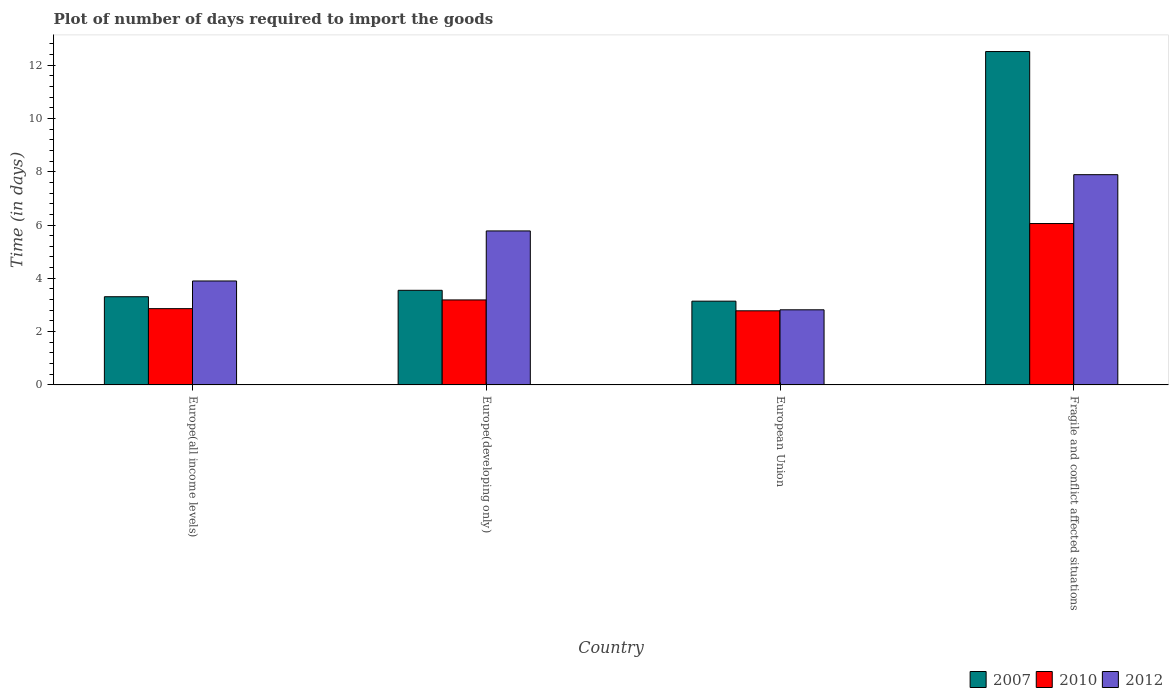How many bars are there on the 2nd tick from the right?
Ensure brevity in your answer.  3. What is the label of the 2nd group of bars from the left?
Provide a succinct answer. Europe(developing only). In how many cases, is the number of bars for a given country not equal to the number of legend labels?
Provide a succinct answer. 0. What is the time required to import goods in 2012 in Fragile and conflict affected situations?
Keep it short and to the point. 7.89. Across all countries, what is the maximum time required to import goods in 2012?
Ensure brevity in your answer.  7.89. Across all countries, what is the minimum time required to import goods in 2007?
Your answer should be very brief. 3.14. In which country was the time required to import goods in 2007 maximum?
Give a very brief answer. Fragile and conflict affected situations. In which country was the time required to import goods in 2012 minimum?
Your answer should be very brief. European Union. What is the total time required to import goods in 2010 in the graph?
Your answer should be very brief. 14.89. What is the difference between the time required to import goods in 2010 in Europe(developing only) and that in Fragile and conflict affected situations?
Make the answer very short. -2.87. What is the difference between the time required to import goods in 2010 in Europe(developing only) and the time required to import goods in 2012 in Europe(all income levels)?
Offer a very short reply. -0.71. What is the average time required to import goods in 2012 per country?
Offer a terse response. 5.1. What is the difference between the time required to import goods of/in 2012 and time required to import goods of/in 2007 in European Union?
Ensure brevity in your answer.  -0.32. What is the ratio of the time required to import goods in 2010 in Europe(all income levels) to that in Fragile and conflict affected situations?
Provide a short and direct response. 0.47. Is the difference between the time required to import goods in 2012 in Europe(developing only) and Fragile and conflict affected situations greater than the difference between the time required to import goods in 2007 in Europe(developing only) and Fragile and conflict affected situations?
Give a very brief answer. Yes. What is the difference between the highest and the second highest time required to import goods in 2012?
Your response must be concise. -1.88. What is the difference between the highest and the lowest time required to import goods in 2010?
Provide a short and direct response. 3.27. In how many countries, is the time required to import goods in 2010 greater than the average time required to import goods in 2010 taken over all countries?
Your answer should be very brief. 1. Are all the bars in the graph horizontal?
Your response must be concise. No. How many countries are there in the graph?
Provide a short and direct response. 4. What is the difference between two consecutive major ticks on the Y-axis?
Provide a short and direct response. 2. Are the values on the major ticks of Y-axis written in scientific E-notation?
Your response must be concise. No. Does the graph contain any zero values?
Provide a succinct answer. No. Does the graph contain grids?
Offer a very short reply. No. What is the title of the graph?
Provide a succinct answer. Plot of number of days required to import the goods. What is the label or title of the X-axis?
Your answer should be very brief. Country. What is the label or title of the Y-axis?
Offer a very short reply. Time (in days). What is the Time (in days) in 2007 in Europe(all income levels)?
Provide a succinct answer. 3.31. What is the Time (in days) in 2010 in Europe(all income levels)?
Your answer should be compact. 2.86. What is the Time (in days) of 2012 in Europe(all income levels)?
Provide a short and direct response. 3.9. What is the Time (in days) in 2007 in Europe(developing only)?
Ensure brevity in your answer.  3.55. What is the Time (in days) of 2010 in Europe(developing only)?
Offer a very short reply. 3.19. What is the Time (in days) of 2012 in Europe(developing only)?
Offer a very short reply. 5.78. What is the Time (in days) of 2007 in European Union?
Keep it short and to the point. 3.14. What is the Time (in days) of 2010 in European Union?
Keep it short and to the point. 2.78. What is the Time (in days) in 2012 in European Union?
Make the answer very short. 2.82. What is the Time (in days) of 2007 in Fragile and conflict affected situations?
Your answer should be compact. 12.51. What is the Time (in days) in 2010 in Fragile and conflict affected situations?
Provide a succinct answer. 6.05. What is the Time (in days) of 2012 in Fragile and conflict affected situations?
Ensure brevity in your answer.  7.89. Across all countries, what is the maximum Time (in days) of 2007?
Provide a short and direct response. 12.51. Across all countries, what is the maximum Time (in days) of 2010?
Offer a terse response. 6.05. Across all countries, what is the maximum Time (in days) of 2012?
Your answer should be very brief. 7.89. Across all countries, what is the minimum Time (in days) of 2007?
Offer a very short reply. 3.14. Across all countries, what is the minimum Time (in days) of 2010?
Give a very brief answer. 2.78. Across all countries, what is the minimum Time (in days) of 2012?
Make the answer very short. 2.82. What is the total Time (in days) in 2007 in the graph?
Your answer should be compact. 22.51. What is the total Time (in days) of 2010 in the graph?
Offer a very short reply. 14.89. What is the total Time (in days) in 2012 in the graph?
Your response must be concise. 20.38. What is the difference between the Time (in days) in 2007 in Europe(all income levels) and that in Europe(developing only)?
Your answer should be very brief. -0.24. What is the difference between the Time (in days) of 2010 in Europe(all income levels) and that in Europe(developing only)?
Make the answer very short. -0.33. What is the difference between the Time (in days) in 2012 in Europe(all income levels) and that in Europe(developing only)?
Make the answer very short. -1.88. What is the difference between the Time (in days) in 2007 in Europe(all income levels) and that in European Union?
Your answer should be very brief. 0.17. What is the difference between the Time (in days) in 2010 in Europe(all income levels) and that in European Union?
Your answer should be very brief. 0.08. What is the difference between the Time (in days) in 2012 in Europe(all income levels) and that in European Union?
Your answer should be compact. 1.08. What is the difference between the Time (in days) of 2010 in Europe(all income levels) and that in Fragile and conflict affected situations?
Ensure brevity in your answer.  -3.19. What is the difference between the Time (in days) of 2012 in Europe(all income levels) and that in Fragile and conflict affected situations?
Your answer should be compact. -3.99. What is the difference between the Time (in days) in 2007 in Europe(developing only) and that in European Union?
Provide a short and direct response. 0.41. What is the difference between the Time (in days) in 2010 in Europe(developing only) and that in European Union?
Your response must be concise. 0.41. What is the difference between the Time (in days) in 2012 in Europe(developing only) and that in European Union?
Make the answer very short. 2.96. What is the difference between the Time (in days) of 2007 in Europe(developing only) and that in Fragile and conflict affected situations?
Give a very brief answer. -8.96. What is the difference between the Time (in days) in 2010 in Europe(developing only) and that in Fragile and conflict affected situations?
Make the answer very short. -2.87. What is the difference between the Time (in days) of 2012 in Europe(developing only) and that in Fragile and conflict affected situations?
Ensure brevity in your answer.  -2.11. What is the difference between the Time (in days) in 2007 in European Union and that in Fragile and conflict affected situations?
Your answer should be compact. -9.37. What is the difference between the Time (in days) in 2010 in European Union and that in Fragile and conflict affected situations?
Your answer should be very brief. -3.27. What is the difference between the Time (in days) of 2012 in European Union and that in Fragile and conflict affected situations?
Provide a succinct answer. -5.07. What is the difference between the Time (in days) of 2007 in Europe(all income levels) and the Time (in days) of 2010 in Europe(developing only)?
Your answer should be very brief. 0.12. What is the difference between the Time (in days) of 2007 in Europe(all income levels) and the Time (in days) of 2012 in Europe(developing only)?
Provide a short and direct response. -2.47. What is the difference between the Time (in days) of 2010 in Europe(all income levels) and the Time (in days) of 2012 in Europe(developing only)?
Ensure brevity in your answer.  -2.92. What is the difference between the Time (in days) of 2007 in Europe(all income levels) and the Time (in days) of 2010 in European Union?
Offer a terse response. 0.53. What is the difference between the Time (in days) in 2007 in Europe(all income levels) and the Time (in days) in 2012 in European Union?
Your answer should be compact. 0.49. What is the difference between the Time (in days) of 2010 in Europe(all income levels) and the Time (in days) of 2012 in European Union?
Your answer should be compact. 0.04. What is the difference between the Time (in days) of 2007 in Europe(all income levels) and the Time (in days) of 2010 in Fragile and conflict affected situations?
Provide a succinct answer. -2.75. What is the difference between the Time (in days) in 2007 in Europe(all income levels) and the Time (in days) in 2012 in Fragile and conflict affected situations?
Ensure brevity in your answer.  -4.58. What is the difference between the Time (in days) of 2010 in Europe(all income levels) and the Time (in days) of 2012 in Fragile and conflict affected situations?
Provide a short and direct response. -5.03. What is the difference between the Time (in days) of 2007 in Europe(developing only) and the Time (in days) of 2010 in European Union?
Your response must be concise. 0.77. What is the difference between the Time (in days) in 2007 in Europe(developing only) and the Time (in days) in 2012 in European Union?
Provide a succinct answer. 0.73. What is the difference between the Time (in days) of 2010 in Europe(developing only) and the Time (in days) of 2012 in European Union?
Your answer should be compact. 0.37. What is the difference between the Time (in days) of 2007 in Europe(developing only) and the Time (in days) of 2010 in Fragile and conflict affected situations?
Make the answer very short. -2.5. What is the difference between the Time (in days) of 2007 in Europe(developing only) and the Time (in days) of 2012 in Fragile and conflict affected situations?
Your answer should be compact. -4.34. What is the difference between the Time (in days) in 2010 in Europe(developing only) and the Time (in days) in 2012 in Fragile and conflict affected situations?
Ensure brevity in your answer.  -4.7. What is the difference between the Time (in days) of 2007 in European Union and the Time (in days) of 2010 in Fragile and conflict affected situations?
Offer a terse response. -2.91. What is the difference between the Time (in days) of 2007 in European Union and the Time (in days) of 2012 in Fragile and conflict affected situations?
Provide a short and direct response. -4.75. What is the difference between the Time (in days) in 2010 in European Union and the Time (in days) in 2012 in Fragile and conflict affected situations?
Keep it short and to the point. -5.11. What is the average Time (in days) of 2007 per country?
Your response must be concise. 5.63. What is the average Time (in days) of 2010 per country?
Keep it short and to the point. 3.72. What is the average Time (in days) in 2012 per country?
Provide a short and direct response. 5.1. What is the difference between the Time (in days) of 2007 and Time (in days) of 2010 in Europe(all income levels)?
Your response must be concise. 0.45. What is the difference between the Time (in days) of 2007 and Time (in days) of 2012 in Europe(all income levels)?
Offer a terse response. -0.59. What is the difference between the Time (in days) of 2010 and Time (in days) of 2012 in Europe(all income levels)?
Ensure brevity in your answer.  -1.04. What is the difference between the Time (in days) of 2007 and Time (in days) of 2010 in Europe(developing only)?
Make the answer very short. 0.36. What is the difference between the Time (in days) of 2007 and Time (in days) of 2012 in Europe(developing only)?
Offer a very short reply. -2.23. What is the difference between the Time (in days) of 2010 and Time (in days) of 2012 in Europe(developing only)?
Offer a terse response. -2.59. What is the difference between the Time (in days) in 2007 and Time (in days) in 2010 in European Union?
Offer a very short reply. 0.36. What is the difference between the Time (in days) in 2007 and Time (in days) in 2012 in European Union?
Ensure brevity in your answer.  0.32. What is the difference between the Time (in days) in 2010 and Time (in days) in 2012 in European Union?
Your answer should be compact. -0.04. What is the difference between the Time (in days) in 2007 and Time (in days) in 2010 in Fragile and conflict affected situations?
Ensure brevity in your answer.  6.45. What is the difference between the Time (in days) of 2007 and Time (in days) of 2012 in Fragile and conflict affected situations?
Make the answer very short. 4.62. What is the difference between the Time (in days) of 2010 and Time (in days) of 2012 in Fragile and conflict affected situations?
Keep it short and to the point. -1.83. What is the ratio of the Time (in days) of 2007 in Europe(all income levels) to that in Europe(developing only)?
Your answer should be very brief. 0.93. What is the ratio of the Time (in days) in 2010 in Europe(all income levels) to that in Europe(developing only)?
Your response must be concise. 0.9. What is the ratio of the Time (in days) in 2012 in Europe(all income levels) to that in Europe(developing only)?
Offer a very short reply. 0.68. What is the ratio of the Time (in days) in 2007 in Europe(all income levels) to that in European Union?
Provide a succinct answer. 1.05. What is the ratio of the Time (in days) of 2010 in Europe(all income levels) to that in European Union?
Your response must be concise. 1.03. What is the ratio of the Time (in days) in 2012 in Europe(all income levels) to that in European Union?
Your response must be concise. 1.38. What is the ratio of the Time (in days) of 2007 in Europe(all income levels) to that in Fragile and conflict affected situations?
Offer a very short reply. 0.26. What is the ratio of the Time (in days) of 2010 in Europe(all income levels) to that in Fragile and conflict affected situations?
Make the answer very short. 0.47. What is the ratio of the Time (in days) of 2012 in Europe(all income levels) to that in Fragile and conflict affected situations?
Offer a terse response. 0.49. What is the ratio of the Time (in days) in 2007 in Europe(developing only) to that in European Union?
Your response must be concise. 1.13. What is the ratio of the Time (in days) of 2010 in Europe(developing only) to that in European Union?
Your response must be concise. 1.15. What is the ratio of the Time (in days) of 2012 in Europe(developing only) to that in European Union?
Ensure brevity in your answer.  2.05. What is the ratio of the Time (in days) of 2007 in Europe(developing only) to that in Fragile and conflict affected situations?
Offer a very short reply. 0.28. What is the ratio of the Time (in days) in 2010 in Europe(developing only) to that in Fragile and conflict affected situations?
Offer a terse response. 0.53. What is the ratio of the Time (in days) of 2012 in Europe(developing only) to that in Fragile and conflict affected situations?
Provide a succinct answer. 0.73. What is the ratio of the Time (in days) in 2007 in European Union to that in Fragile and conflict affected situations?
Provide a succinct answer. 0.25. What is the ratio of the Time (in days) of 2010 in European Union to that in Fragile and conflict affected situations?
Your answer should be compact. 0.46. What is the ratio of the Time (in days) in 2012 in European Union to that in Fragile and conflict affected situations?
Your answer should be very brief. 0.36. What is the difference between the highest and the second highest Time (in days) in 2007?
Keep it short and to the point. 8.96. What is the difference between the highest and the second highest Time (in days) of 2010?
Provide a short and direct response. 2.87. What is the difference between the highest and the second highest Time (in days) in 2012?
Keep it short and to the point. 2.11. What is the difference between the highest and the lowest Time (in days) in 2007?
Offer a terse response. 9.37. What is the difference between the highest and the lowest Time (in days) of 2010?
Your response must be concise. 3.27. What is the difference between the highest and the lowest Time (in days) in 2012?
Give a very brief answer. 5.07. 